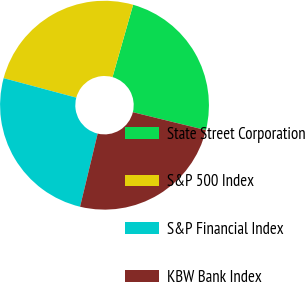<chart> <loc_0><loc_0><loc_500><loc_500><pie_chart><fcel>State Street Corporation<fcel>S&P 500 Index<fcel>S&P Financial Index<fcel>KBW Bank Index<nl><fcel>24.42%<fcel>25.25%<fcel>25.41%<fcel>24.92%<nl></chart> 